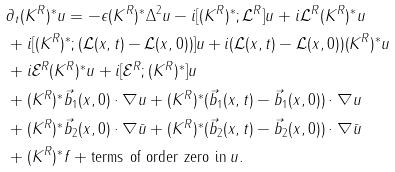<formula> <loc_0><loc_0><loc_500><loc_500>& \partial _ { t } ( K ^ { R } ) ^ { * } u = - \epsilon ( K ^ { R } ) ^ { * } \Delta ^ { 2 } u - i [ ( K ^ { R } ) ^ { * } ; \mathcal { L } ^ { R } ] u + i \mathcal { L } ^ { R } ( K ^ { R } ) ^ { * } u \\ & + i [ ( K ^ { R } ) ^ { * } ; ( \mathcal { L } ( x , t ) - \mathcal { L } ( x , 0 ) ) ] u + i ( \mathcal { L } ( x , t ) - \mathcal { L } ( x , 0 ) ) ( K ^ { R } ) ^ { * } u \\ & + i \mathcal { E } ^ { R } ( K ^ { R } ) ^ { * } u + i [ \mathcal { E } ^ { R } ; ( K ^ { R } ) ^ { * } ] u \\ & + ( K ^ { R } ) ^ { * } \vec { b } _ { 1 } ( x , 0 ) \cdot \nabla u + ( K ^ { R } ) ^ { * } ( \vec { b } _ { 1 } ( x , t ) - \vec { b } _ { 1 } ( x , 0 ) ) \cdot \nabla u \\ & + ( K ^ { R } ) ^ { * } \vec { b } _ { 2 } ( x , 0 ) \cdot \nabla \bar { u } + ( K ^ { R } ) ^ { * } ( \vec { b } _ { 2 } ( x , t ) - \vec { b } _ { 2 } ( x , 0 ) ) \cdot \nabla \bar { u } \\ & + ( K ^ { R } ) ^ { * } f + \text {terms of order zero in} \, u .</formula> 